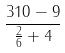<formula> <loc_0><loc_0><loc_500><loc_500>\frac { 3 1 0 - 9 } { \frac { 2 } { 6 } + 4 }</formula> 